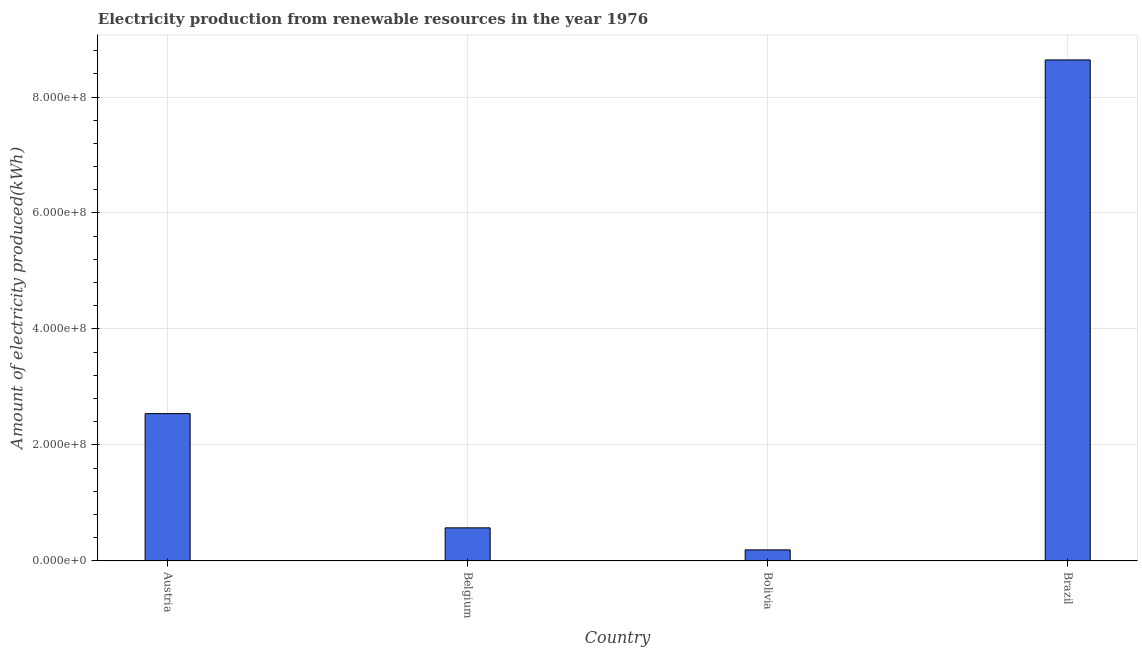Does the graph contain grids?
Provide a short and direct response. Yes. What is the title of the graph?
Ensure brevity in your answer.  Electricity production from renewable resources in the year 1976. What is the label or title of the X-axis?
Provide a short and direct response. Country. What is the label or title of the Y-axis?
Give a very brief answer. Amount of electricity produced(kWh). What is the amount of electricity produced in Bolivia?
Keep it short and to the point. 1.90e+07. Across all countries, what is the maximum amount of electricity produced?
Offer a terse response. 8.64e+08. Across all countries, what is the minimum amount of electricity produced?
Your response must be concise. 1.90e+07. In which country was the amount of electricity produced maximum?
Your answer should be very brief. Brazil. In which country was the amount of electricity produced minimum?
Your answer should be compact. Bolivia. What is the sum of the amount of electricity produced?
Offer a terse response. 1.19e+09. What is the difference between the amount of electricity produced in Belgium and Brazil?
Provide a short and direct response. -8.07e+08. What is the average amount of electricity produced per country?
Provide a short and direct response. 2.98e+08. What is the median amount of electricity produced?
Provide a short and direct response. 1.56e+08. What is the ratio of the amount of electricity produced in Belgium to that in Brazil?
Make the answer very short. 0.07. Is the difference between the amount of electricity produced in Austria and Bolivia greater than the difference between any two countries?
Your response must be concise. No. What is the difference between the highest and the second highest amount of electricity produced?
Provide a succinct answer. 6.10e+08. What is the difference between the highest and the lowest amount of electricity produced?
Your response must be concise. 8.45e+08. In how many countries, is the amount of electricity produced greater than the average amount of electricity produced taken over all countries?
Ensure brevity in your answer.  1. How many bars are there?
Provide a short and direct response. 4. Are all the bars in the graph horizontal?
Provide a succinct answer. No. How many countries are there in the graph?
Provide a succinct answer. 4. What is the Amount of electricity produced(kWh) of Austria?
Give a very brief answer. 2.54e+08. What is the Amount of electricity produced(kWh) of Belgium?
Your answer should be very brief. 5.70e+07. What is the Amount of electricity produced(kWh) in Bolivia?
Ensure brevity in your answer.  1.90e+07. What is the Amount of electricity produced(kWh) of Brazil?
Keep it short and to the point. 8.64e+08. What is the difference between the Amount of electricity produced(kWh) in Austria and Belgium?
Your answer should be compact. 1.97e+08. What is the difference between the Amount of electricity produced(kWh) in Austria and Bolivia?
Your answer should be compact. 2.35e+08. What is the difference between the Amount of electricity produced(kWh) in Austria and Brazil?
Your response must be concise. -6.10e+08. What is the difference between the Amount of electricity produced(kWh) in Belgium and Bolivia?
Ensure brevity in your answer.  3.80e+07. What is the difference between the Amount of electricity produced(kWh) in Belgium and Brazil?
Offer a very short reply. -8.07e+08. What is the difference between the Amount of electricity produced(kWh) in Bolivia and Brazil?
Your answer should be very brief. -8.45e+08. What is the ratio of the Amount of electricity produced(kWh) in Austria to that in Belgium?
Your response must be concise. 4.46. What is the ratio of the Amount of electricity produced(kWh) in Austria to that in Bolivia?
Provide a short and direct response. 13.37. What is the ratio of the Amount of electricity produced(kWh) in Austria to that in Brazil?
Your response must be concise. 0.29. What is the ratio of the Amount of electricity produced(kWh) in Belgium to that in Brazil?
Provide a succinct answer. 0.07. What is the ratio of the Amount of electricity produced(kWh) in Bolivia to that in Brazil?
Offer a very short reply. 0.02. 